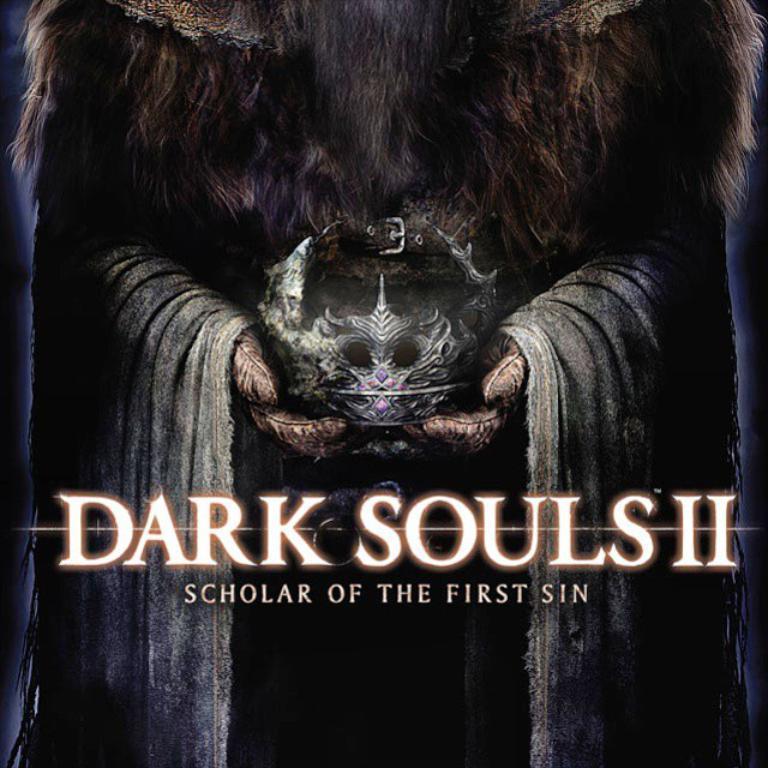How would you summarize this image in a sentence or two? In this image there is a poster, there is a person holding a crown, there is text. 